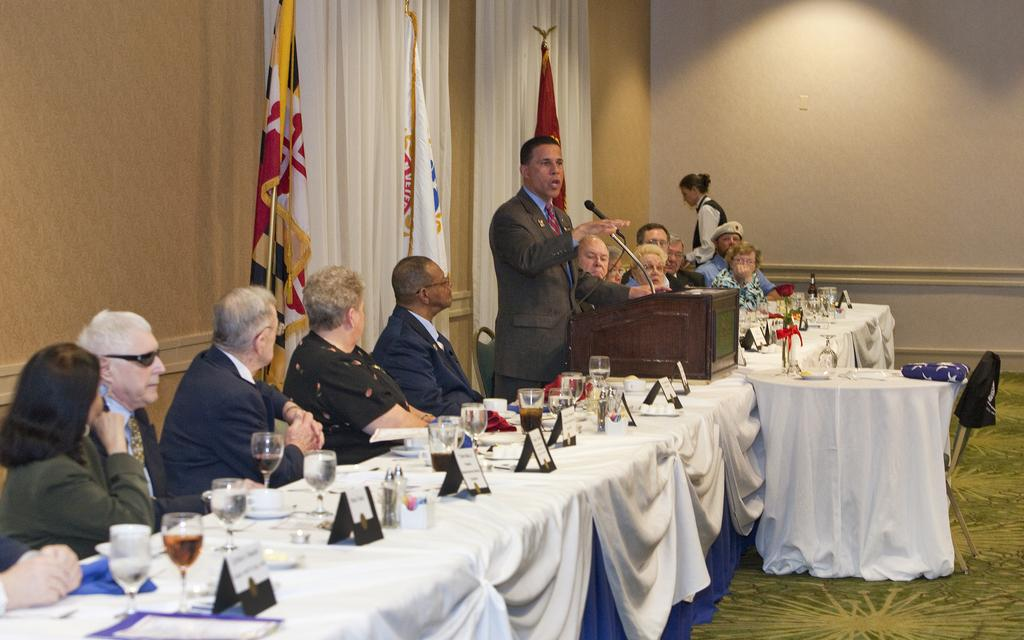What can be seen on the wall in the image? There is a wall in the image, but no specific details are provided about what is on the wall. What type of window treatment is present in the image? There are curtains in the image. What type of decorations are visible in the image? There are flags in the image. What are the people in the image doing? There are people sitting on chairs in the image. What is on the table in the image? There is a table in the image with glasses, plates, bowls, and papers on it. Can you describe the motion of the girl in the image? There is no girl present in the image. What type of bath is visible in the image? There is no bath present in the image. 